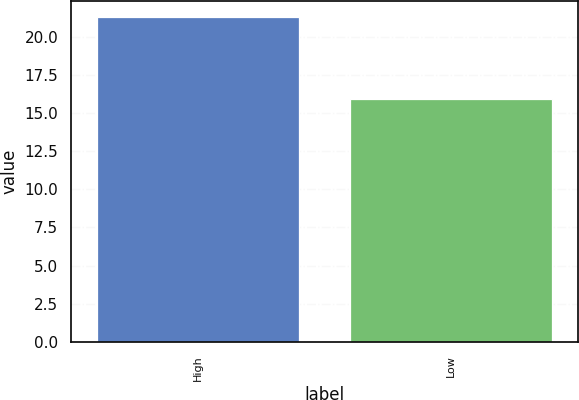<chart> <loc_0><loc_0><loc_500><loc_500><bar_chart><fcel>High<fcel>Low<nl><fcel>21.32<fcel>15.97<nl></chart> 